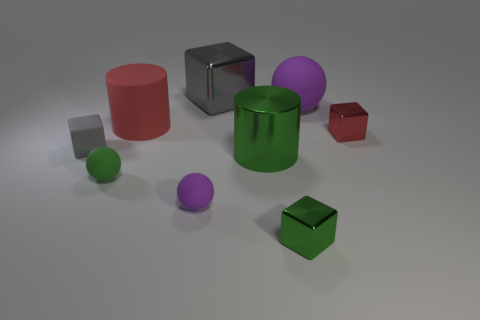Subtract 1 cubes. How many cubes are left? 3 Subtract all spheres. How many objects are left? 6 Add 5 purple objects. How many purple objects exist? 7 Subtract 0 yellow cylinders. How many objects are left? 9 Subtract all spheres. Subtract all big brown blocks. How many objects are left? 6 Add 2 green metal cubes. How many green metal cubes are left? 3 